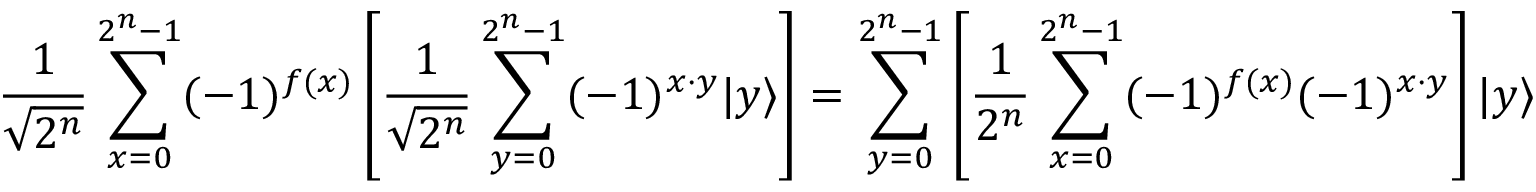Convert formula to latex. <formula><loc_0><loc_0><loc_500><loc_500>{ \frac { 1 } { \sqrt { 2 ^ { n } } } } \sum _ { x = 0 } ^ { 2 ^ { n } - 1 } ( - 1 ) ^ { f ( x ) } \left [ { \frac { 1 } { \sqrt { 2 ^ { n } } } } \sum _ { y = 0 } ^ { 2 ^ { n } - 1 } ( - 1 ) ^ { x \cdot y } | y \rangle \right ] = \sum _ { y = 0 } ^ { 2 ^ { n } - 1 } \left [ { \frac { 1 } { 2 ^ { n } } } \sum _ { x = 0 } ^ { 2 ^ { n } - 1 } ( - 1 ) ^ { f ( x ) } ( - 1 ) ^ { x \cdot y } \right ] | y \rangle</formula> 